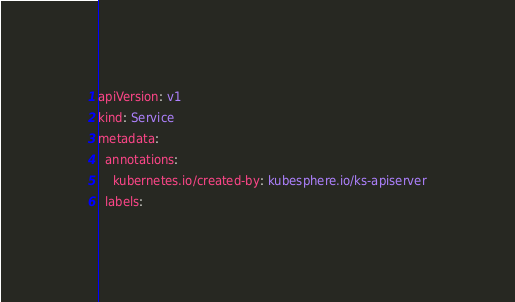Convert code to text. <code><loc_0><loc_0><loc_500><loc_500><_YAML_>apiVersion: v1
kind: Service
metadata:
  annotations:
    kubernetes.io/created-by: kubesphere.io/ks-apiserver
  labels:</code> 